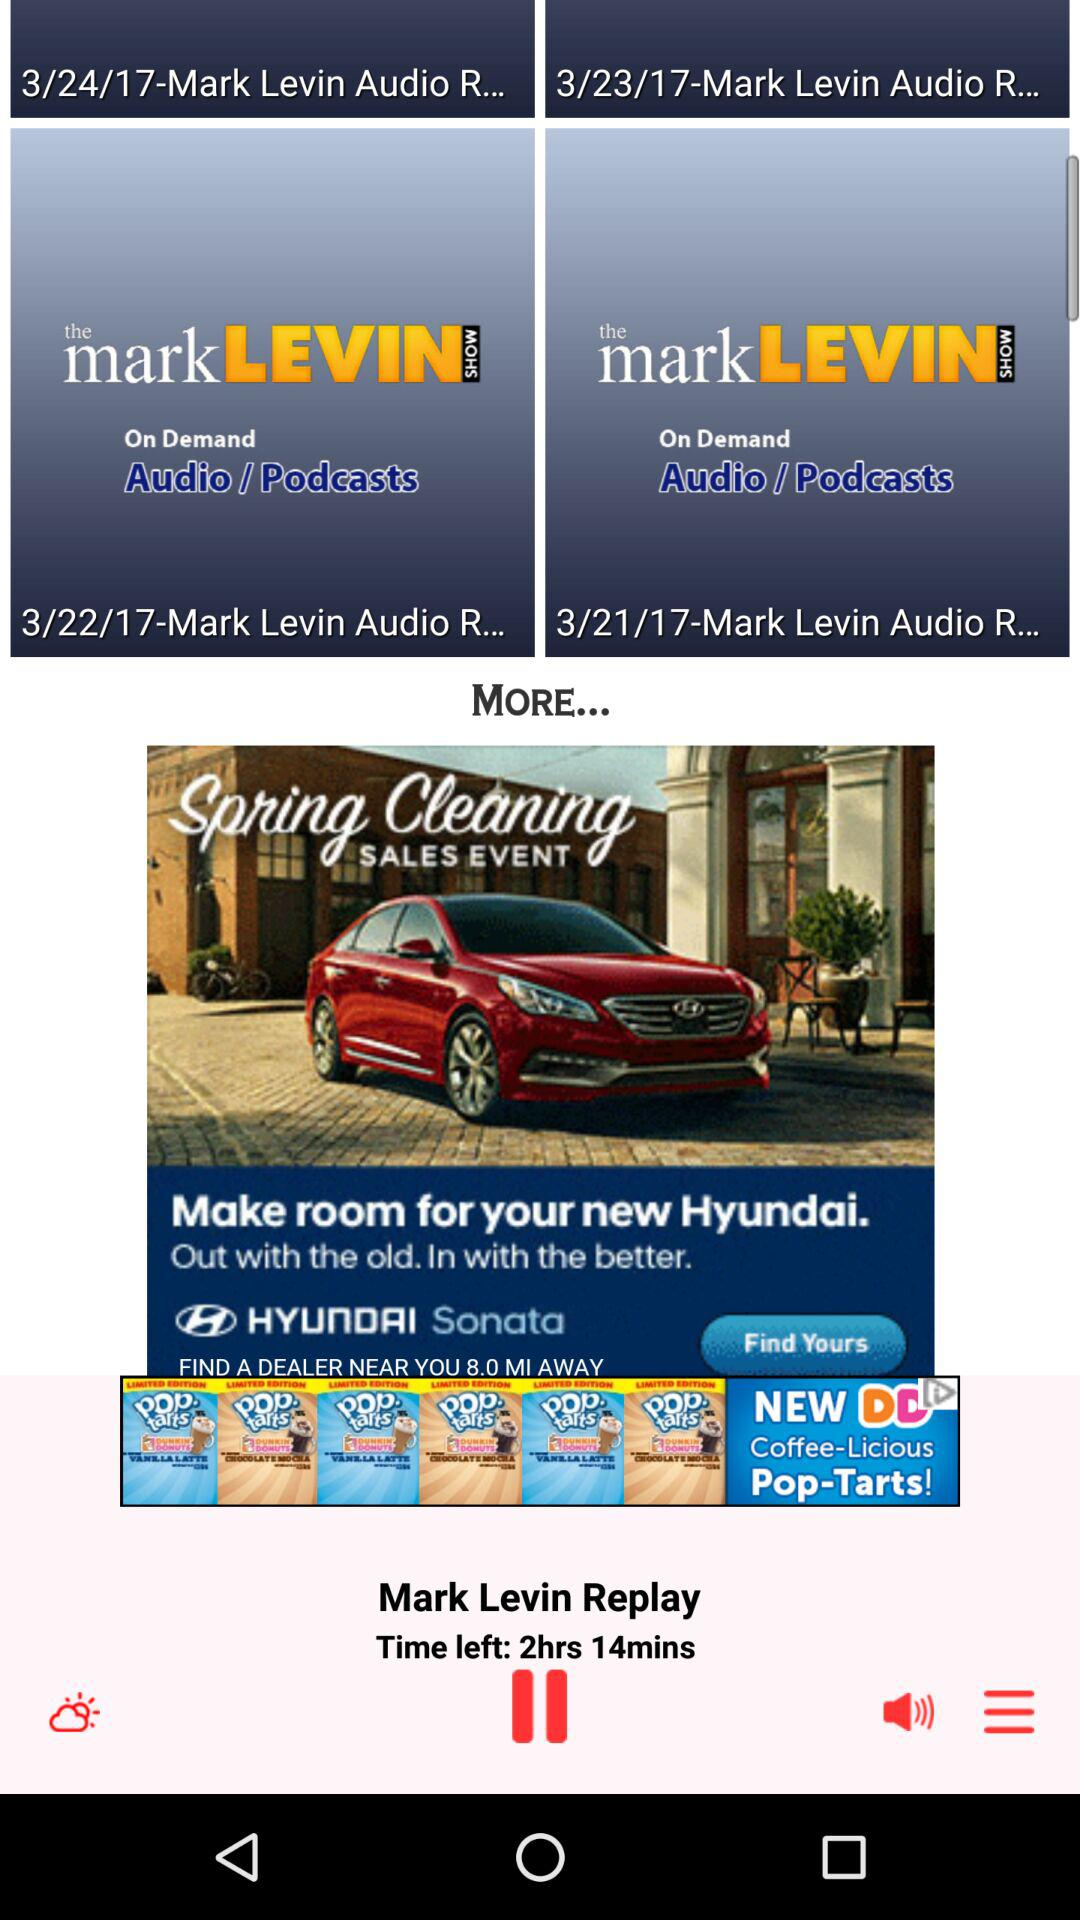How much time is left? There are 2 hours and 14 minutes left. 